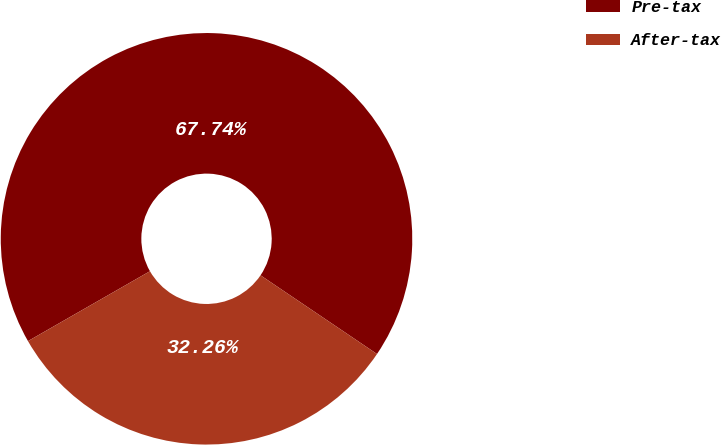Convert chart. <chart><loc_0><loc_0><loc_500><loc_500><pie_chart><fcel>Pre-tax<fcel>After-tax<nl><fcel>67.74%<fcel>32.26%<nl></chart> 